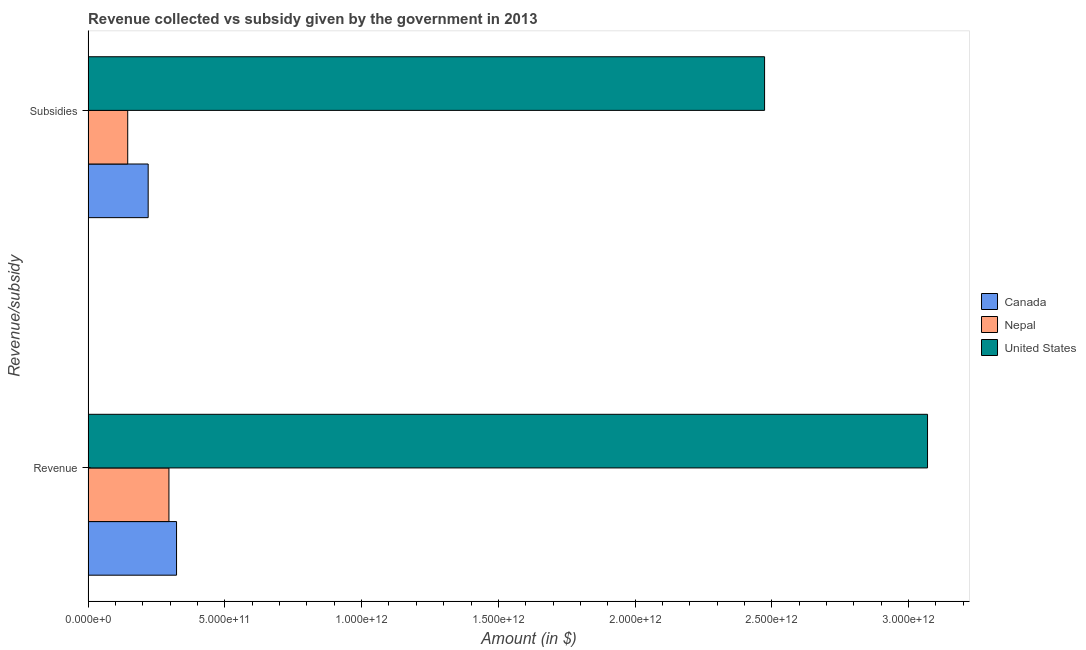How many different coloured bars are there?
Your answer should be very brief. 3. Are the number of bars per tick equal to the number of legend labels?
Your answer should be very brief. Yes. Are the number of bars on each tick of the Y-axis equal?
Give a very brief answer. Yes. How many bars are there on the 1st tick from the bottom?
Keep it short and to the point. 3. What is the label of the 2nd group of bars from the top?
Provide a succinct answer. Revenue. What is the amount of subsidies given in Nepal?
Keep it short and to the point. 1.45e+11. Across all countries, what is the maximum amount of subsidies given?
Provide a succinct answer. 2.47e+12. Across all countries, what is the minimum amount of revenue collected?
Give a very brief answer. 2.96e+11. In which country was the amount of subsidies given minimum?
Give a very brief answer. Nepal. What is the total amount of subsidies given in the graph?
Make the answer very short. 2.84e+12. What is the difference between the amount of revenue collected in Canada and that in United States?
Your answer should be very brief. -2.75e+12. What is the difference between the amount of revenue collected in Nepal and the amount of subsidies given in Canada?
Offer a very short reply. 7.59e+1. What is the average amount of subsidies given per country?
Make the answer very short. 9.46e+11. What is the difference between the amount of subsidies given and amount of revenue collected in Nepal?
Offer a terse response. -1.51e+11. What is the ratio of the amount of revenue collected in Nepal to that in United States?
Your answer should be compact. 0.1. Is the amount of revenue collected in United States less than that in Nepal?
Your response must be concise. No. In how many countries, is the amount of subsidies given greater than the average amount of subsidies given taken over all countries?
Provide a short and direct response. 1. How many bars are there?
Provide a succinct answer. 6. How many countries are there in the graph?
Offer a terse response. 3. What is the difference between two consecutive major ticks on the X-axis?
Your answer should be very brief. 5.00e+11. Are the values on the major ticks of X-axis written in scientific E-notation?
Give a very brief answer. Yes. Where does the legend appear in the graph?
Offer a terse response. Center right. How many legend labels are there?
Your response must be concise. 3. What is the title of the graph?
Offer a very short reply. Revenue collected vs subsidy given by the government in 2013. Does "Middle East & North Africa (all income levels)" appear as one of the legend labels in the graph?
Your answer should be compact. No. What is the label or title of the X-axis?
Your answer should be compact. Amount (in $). What is the label or title of the Y-axis?
Ensure brevity in your answer.  Revenue/subsidy. What is the Amount (in $) of Canada in Revenue?
Offer a very short reply. 3.23e+11. What is the Amount (in $) in Nepal in Revenue?
Ensure brevity in your answer.  2.96e+11. What is the Amount (in $) in United States in Revenue?
Keep it short and to the point. 3.07e+12. What is the Amount (in $) of Canada in Subsidies?
Your answer should be compact. 2.20e+11. What is the Amount (in $) of Nepal in Subsidies?
Offer a terse response. 1.45e+11. What is the Amount (in $) of United States in Subsidies?
Offer a terse response. 2.47e+12. Across all Revenue/subsidy, what is the maximum Amount (in $) in Canada?
Your answer should be compact. 3.23e+11. Across all Revenue/subsidy, what is the maximum Amount (in $) in Nepal?
Your answer should be compact. 2.96e+11. Across all Revenue/subsidy, what is the maximum Amount (in $) in United States?
Provide a short and direct response. 3.07e+12. Across all Revenue/subsidy, what is the minimum Amount (in $) in Canada?
Offer a very short reply. 2.20e+11. Across all Revenue/subsidy, what is the minimum Amount (in $) in Nepal?
Provide a short and direct response. 1.45e+11. Across all Revenue/subsidy, what is the minimum Amount (in $) of United States?
Make the answer very short. 2.47e+12. What is the total Amount (in $) of Canada in the graph?
Provide a succinct answer. 5.43e+11. What is the total Amount (in $) of Nepal in the graph?
Give a very brief answer. 4.40e+11. What is the total Amount (in $) in United States in the graph?
Offer a very short reply. 5.54e+12. What is the difference between the Amount (in $) of Canada in Revenue and that in Subsidies?
Make the answer very short. 1.04e+11. What is the difference between the Amount (in $) of Nepal in Revenue and that in Subsidies?
Offer a very short reply. 1.51e+11. What is the difference between the Amount (in $) in United States in Revenue and that in Subsidies?
Your response must be concise. 5.96e+11. What is the difference between the Amount (in $) of Canada in Revenue and the Amount (in $) of Nepal in Subsidies?
Keep it short and to the point. 1.79e+11. What is the difference between the Amount (in $) in Canada in Revenue and the Amount (in $) in United States in Subsidies?
Make the answer very short. -2.15e+12. What is the difference between the Amount (in $) in Nepal in Revenue and the Amount (in $) in United States in Subsidies?
Ensure brevity in your answer.  -2.18e+12. What is the average Amount (in $) of Canada per Revenue/subsidy?
Give a very brief answer. 2.72e+11. What is the average Amount (in $) in Nepal per Revenue/subsidy?
Ensure brevity in your answer.  2.20e+11. What is the average Amount (in $) of United States per Revenue/subsidy?
Provide a succinct answer. 2.77e+12. What is the difference between the Amount (in $) in Canada and Amount (in $) in Nepal in Revenue?
Your answer should be very brief. 2.78e+1. What is the difference between the Amount (in $) in Canada and Amount (in $) in United States in Revenue?
Offer a terse response. -2.75e+12. What is the difference between the Amount (in $) of Nepal and Amount (in $) of United States in Revenue?
Keep it short and to the point. -2.77e+12. What is the difference between the Amount (in $) of Canada and Amount (in $) of Nepal in Subsidies?
Provide a short and direct response. 7.48e+1. What is the difference between the Amount (in $) of Canada and Amount (in $) of United States in Subsidies?
Provide a succinct answer. -2.25e+12. What is the difference between the Amount (in $) of Nepal and Amount (in $) of United States in Subsidies?
Give a very brief answer. -2.33e+12. What is the ratio of the Amount (in $) of Canada in Revenue to that in Subsidies?
Offer a terse response. 1.47. What is the ratio of the Amount (in $) of Nepal in Revenue to that in Subsidies?
Offer a terse response. 2.04. What is the ratio of the Amount (in $) in United States in Revenue to that in Subsidies?
Your answer should be compact. 1.24. What is the difference between the highest and the second highest Amount (in $) of Canada?
Your answer should be compact. 1.04e+11. What is the difference between the highest and the second highest Amount (in $) in Nepal?
Your answer should be very brief. 1.51e+11. What is the difference between the highest and the second highest Amount (in $) in United States?
Give a very brief answer. 5.96e+11. What is the difference between the highest and the lowest Amount (in $) in Canada?
Your answer should be very brief. 1.04e+11. What is the difference between the highest and the lowest Amount (in $) in Nepal?
Offer a very short reply. 1.51e+11. What is the difference between the highest and the lowest Amount (in $) of United States?
Provide a short and direct response. 5.96e+11. 